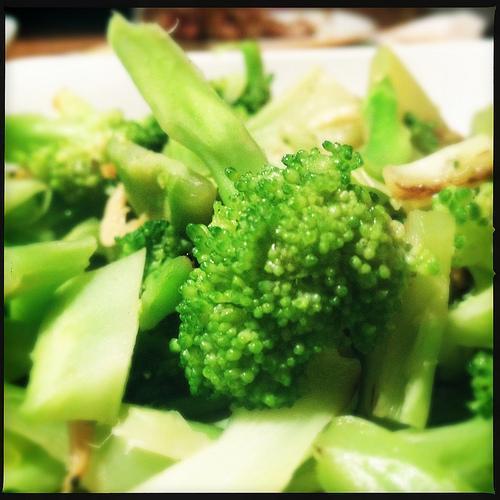How many plates are visible?
Give a very brief answer. 1. 